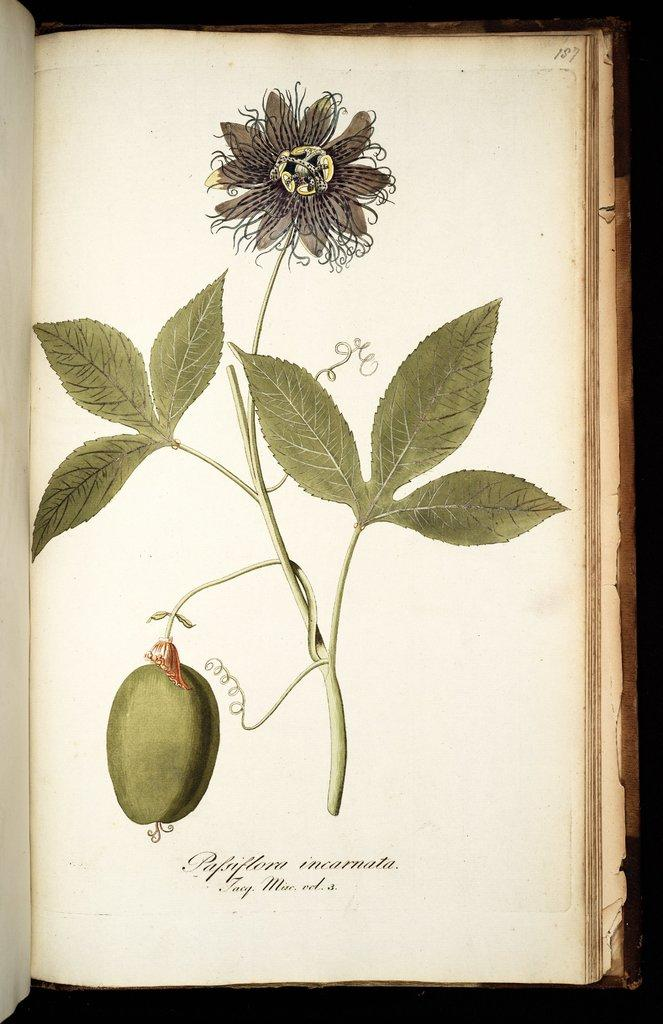What is the main object in the image? There is a book in the image. What is depicted in the book? The book contains a drawing of a plant. Is there any text in the book? Yes, there is writing in the book. How many beads are scattered around the book in the image? There are no beads present in the image. What type of squirrel can be seen interacting with the plant drawing in the book? There is no squirrel present in the image, and the book is not interactive in that way. 